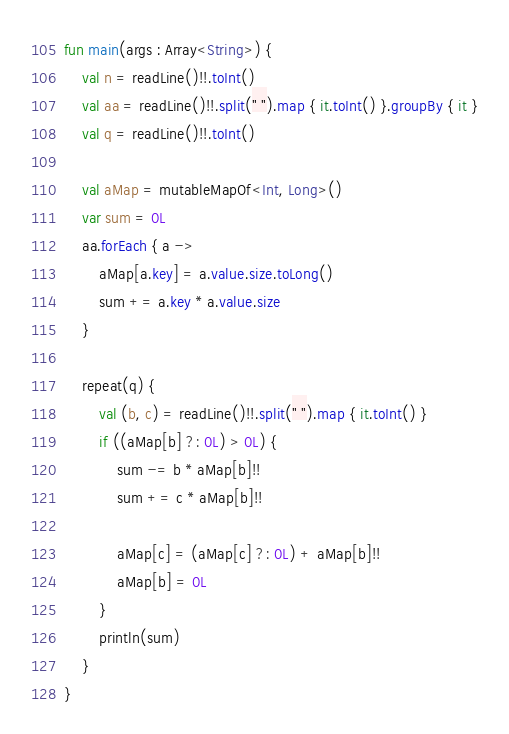Convert code to text. <code><loc_0><loc_0><loc_500><loc_500><_Kotlin_>fun main(args : Array<String>) {
    val n = readLine()!!.toInt()
    val aa = readLine()!!.split(" ").map { it.toInt() }.groupBy { it }
    val q = readLine()!!.toInt()

    val aMap = mutableMapOf<Int, Long>()
    var sum = 0L
    aa.forEach { a ->
        aMap[a.key] = a.value.size.toLong()
        sum += a.key * a.value.size
    }

    repeat(q) {
        val (b, c) = readLine()!!.split(" ").map { it.toInt() }
        if ((aMap[b] ?: 0L) > 0L) {
            sum -= b * aMap[b]!!
            sum += c * aMap[b]!!

            aMap[c] = (aMap[c] ?: 0L) + aMap[b]!!
            aMap[b] = 0L
        }
        println(sum)
    }
}</code> 